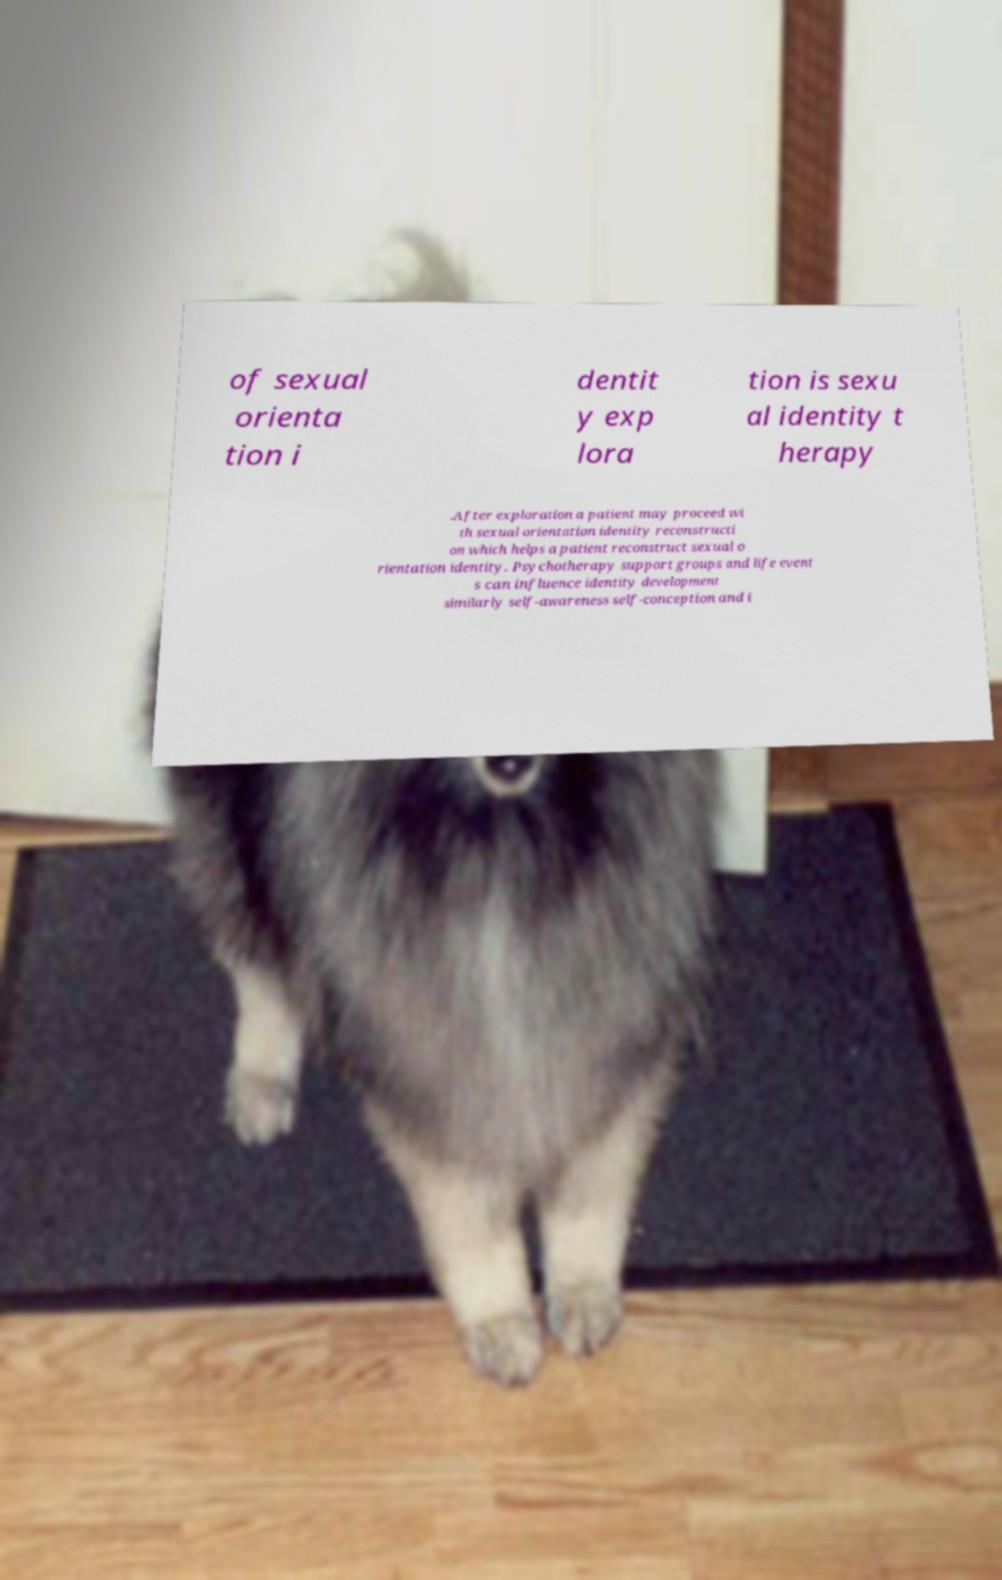Please read and relay the text visible in this image. What does it say? of sexual orienta tion i dentit y exp lora tion is sexu al identity t herapy .After exploration a patient may proceed wi th sexual orientation identity reconstructi on which helps a patient reconstruct sexual o rientation identity. Psychotherapy support groups and life event s can influence identity development similarly self-awareness self-conception and i 